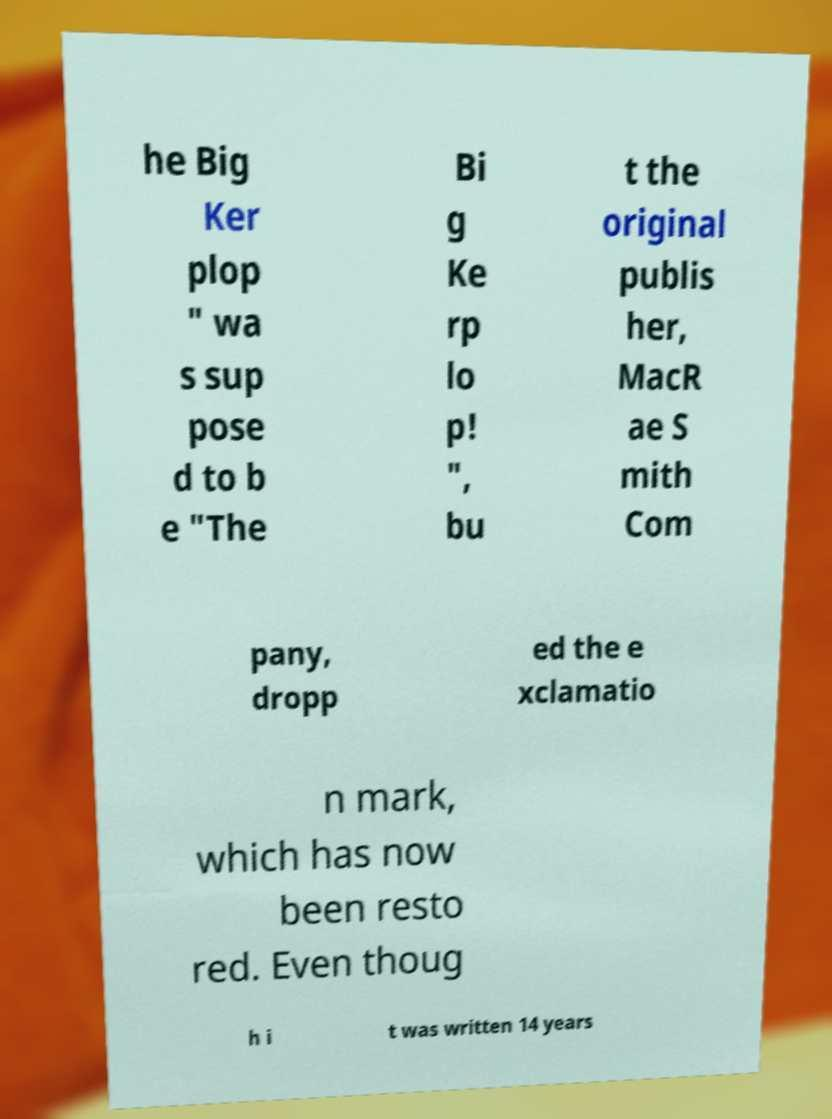Can you read and provide the text displayed in the image?This photo seems to have some interesting text. Can you extract and type it out for me? he Big Ker plop " wa s sup pose d to b e "The Bi g Ke rp lo p! ", bu t the original publis her, MacR ae S mith Com pany, dropp ed the e xclamatio n mark, which has now been resto red. Even thoug h i t was written 14 years 